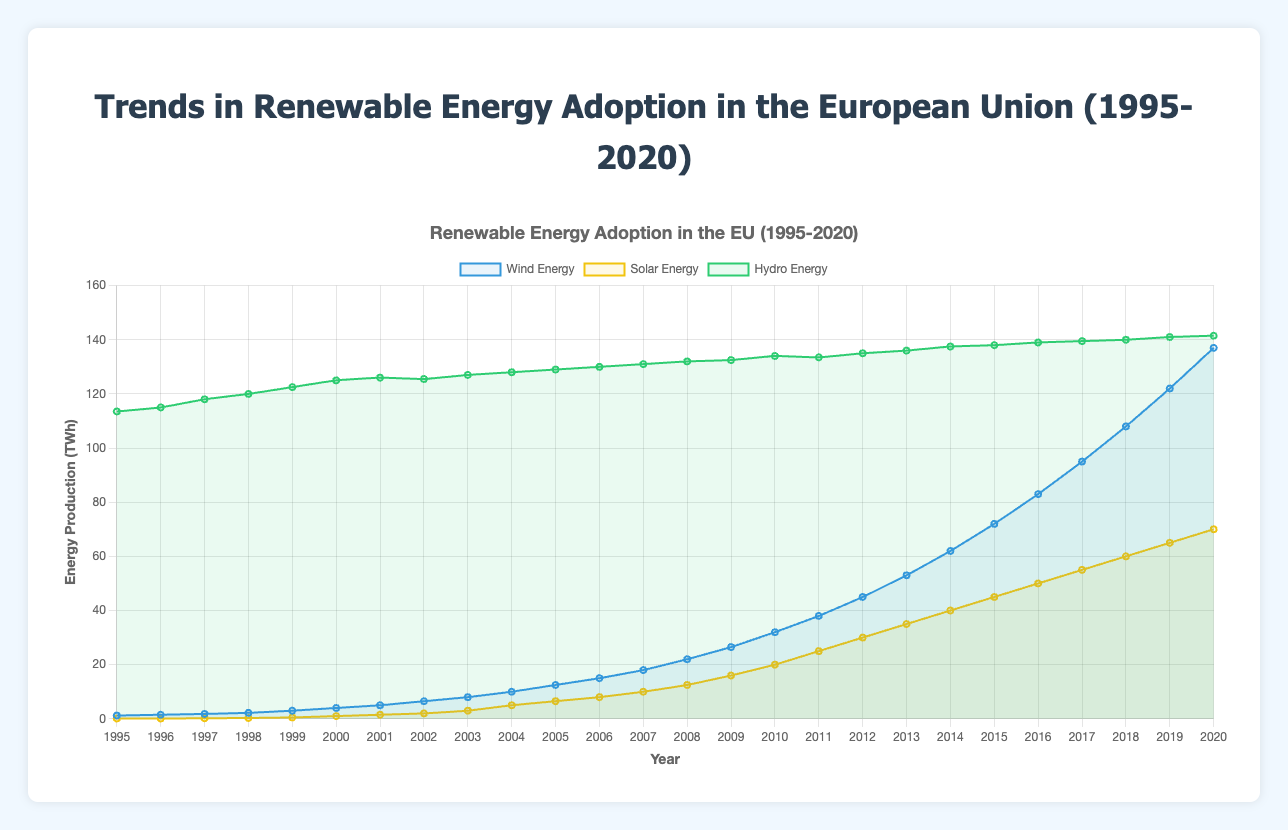what is the total production of wind energy, solar energy, and hydro energy in 1995? To find the total, sum up the production of wind energy, solar energy, and hydro energy for the year 1995: 1.2 (wind) + 0.1 (solar) + 113.5 (hydro) = 114.8 TWh
Answer: 114.8 TWh how does the trend in solar energy between 2000 and 2020 compare to the trend in wind energy during the same period? From the figure, solar energy starts at 1.0 TWh in 2000 and increases to 70.0 TWh in 2020, showing a significant upward trend. Wind energy starts at 4.0 TWh in 2000 and rises to 137.0 TWh in 2020, also showing a significant upward trend. Thus, both show significant increases, but wind energy experiences a sharper rise.
Answer: Wind energy has a sharper increase which year did wind energy surpass hydro energy for the first time? By examining the lines in the figure, wind energy first surpasses hydro energy when the wind energy line crosses above the hydro energy line. This happens in 2018.
Answer: 2018 how much more wind energy was produced than solar energy in 2015? Find the production difference between wind and solar energy: 72.0 (wind) - 45.0 (solar) = 27.0 TWh
Answer: 27.0 TWh describe the visual trend of hydro energy production from 1995 to 2020. Observing the hydro energy line, it shows a steady but slight upward trend from 113.5 TWh in 1995 to 141.5 TWh in 2020, indicating a gradual increase over the years.
Answer: Steady upward trend in which year did solar energy reach 30 TWh? By locating when the solar energy line intersects the 30 TWh mark, solar energy reaches 30 TWh in the year 2012.
Answer: 2012 compare the highest production year of wind energy to the highest production year of solar energy. The highest production of wind energy is 137.0 TWh in 2020, and the highest production of solar energy is 70.0 TWh in 2020. Both have their highest production in the year 2020.
Answer: Both in 2020 